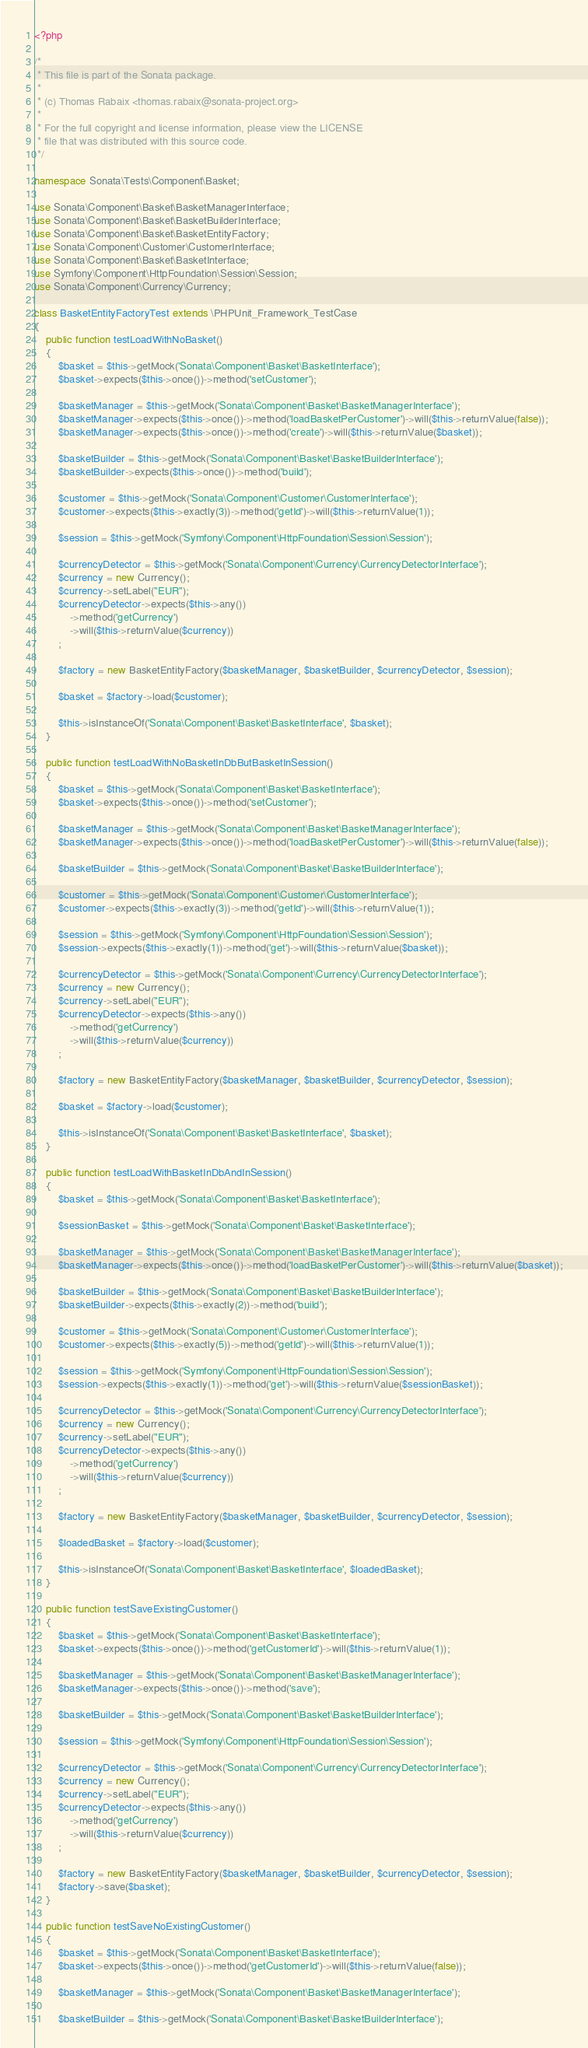<code> <loc_0><loc_0><loc_500><loc_500><_PHP_><?php

/*
 * This file is part of the Sonata package.
 *
 * (c) Thomas Rabaix <thomas.rabaix@sonata-project.org>
 *
 * For the full copyright and license information, please view the LICENSE
 * file that was distributed with this source code.
 */

namespace Sonata\Tests\Component\Basket;

use Sonata\Component\Basket\BasketManagerInterface;
use Sonata\Component\Basket\BasketBuilderInterface;
use Sonata\Component\Basket\BasketEntityFactory;
use Sonata\Component\Customer\CustomerInterface;
use Sonata\Component\Basket\BasketInterface;
use Symfony\Component\HttpFoundation\Session\Session;
use Sonata\Component\Currency\Currency;

class BasketEntityFactoryTest extends \PHPUnit_Framework_TestCase
{
    public function testLoadWithNoBasket()
    {
        $basket = $this->getMock('Sonata\Component\Basket\BasketInterface');
        $basket->expects($this->once())->method('setCustomer');

        $basketManager = $this->getMock('Sonata\Component\Basket\BasketManagerInterface');
        $basketManager->expects($this->once())->method('loadBasketPerCustomer')->will($this->returnValue(false));
        $basketManager->expects($this->once())->method('create')->will($this->returnValue($basket));

        $basketBuilder = $this->getMock('Sonata\Component\Basket\BasketBuilderInterface');
        $basketBuilder->expects($this->once())->method('build');

        $customer = $this->getMock('Sonata\Component\Customer\CustomerInterface');
        $customer->expects($this->exactly(3))->method('getId')->will($this->returnValue(1));

        $session = $this->getMock('Symfony\Component\HttpFoundation\Session\Session');

        $currencyDetector = $this->getMock('Sonata\Component\Currency\CurrencyDetectorInterface');
        $currency = new Currency();
        $currency->setLabel("EUR");
        $currencyDetector->expects($this->any())
            ->method('getCurrency')
            ->will($this->returnValue($currency))
        ;

        $factory = new BasketEntityFactory($basketManager, $basketBuilder, $currencyDetector, $session);

        $basket = $factory->load($customer);

        $this->isInstanceOf('Sonata\Component\Basket\BasketInterface', $basket);
    }

    public function testLoadWithNoBasketInDbButBasketInSession()
    {
        $basket = $this->getMock('Sonata\Component\Basket\BasketInterface');
        $basket->expects($this->once())->method('setCustomer');

        $basketManager = $this->getMock('Sonata\Component\Basket\BasketManagerInterface');
        $basketManager->expects($this->once())->method('loadBasketPerCustomer')->will($this->returnValue(false));

        $basketBuilder = $this->getMock('Sonata\Component\Basket\BasketBuilderInterface');

        $customer = $this->getMock('Sonata\Component\Customer\CustomerInterface');
        $customer->expects($this->exactly(3))->method('getId')->will($this->returnValue(1));

        $session = $this->getMock('Symfony\Component\HttpFoundation\Session\Session');
        $session->expects($this->exactly(1))->method('get')->will($this->returnValue($basket));

        $currencyDetector = $this->getMock('Sonata\Component\Currency\CurrencyDetectorInterface');
        $currency = new Currency();
        $currency->setLabel("EUR");
        $currencyDetector->expects($this->any())
            ->method('getCurrency')
            ->will($this->returnValue($currency))
        ;

        $factory = new BasketEntityFactory($basketManager, $basketBuilder, $currencyDetector, $session);

        $basket = $factory->load($customer);

        $this->isInstanceOf('Sonata\Component\Basket\BasketInterface', $basket);
    }

    public function testLoadWithBasketInDbAndInSession()
    {
        $basket = $this->getMock('Sonata\Component\Basket\BasketInterface');

        $sessionBasket = $this->getMock('Sonata\Component\Basket\BasketInterface');

        $basketManager = $this->getMock('Sonata\Component\Basket\BasketManagerInterface');
        $basketManager->expects($this->once())->method('loadBasketPerCustomer')->will($this->returnValue($basket));

        $basketBuilder = $this->getMock('Sonata\Component\Basket\BasketBuilderInterface');
        $basketBuilder->expects($this->exactly(2))->method('build');

        $customer = $this->getMock('Sonata\Component\Customer\CustomerInterface');
        $customer->expects($this->exactly(5))->method('getId')->will($this->returnValue(1));

        $session = $this->getMock('Symfony\Component\HttpFoundation\Session\Session');
        $session->expects($this->exactly(1))->method('get')->will($this->returnValue($sessionBasket));

        $currencyDetector = $this->getMock('Sonata\Component\Currency\CurrencyDetectorInterface');
        $currency = new Currency();
        $currency->setLabel("EUR");
        $currencyDetector->expects($this->any())
            ->method('getCurrency')
            ->will($this->returnValue($currency))
        ;

        $factory = new BasketEntityFactory($basketManager, $basketBuilder, $currencyDetector, $session);

        $loadedBasket = $factory->load($customer);

        $this->isInstanceOf('Sonata\Component\Basket\BasketInterface', $loadedBasket);
    }

    public function testSaveExistingCustomer()
    {
        $basket = $this->getMock('Sonata\Component\Basket\BasketInterface');
        $basket->expects($this->once())->method('getCustomerId')->will($this->returnValue(1));

        $basketManager = $this->getMock('Sonata\Component\Basket\BasketManagerInterface');
        $basketManager->expects($this->once())->method('save');

        $basketBuilder = $this->getMock('Sonata\Component\Basket\BasketBuilderInterface');

        $session = $this->getMock('Symfony\Component\HttpFoundation\Session\Session');

        $currencyDetector = $this->getMock('Sonata\Component\Currency\CurrencyDetectorInterface');
        $currency = new Currency();
        $currency->setLabel("EUR");
        $currencyDetector->expects($this->any())
            ->method('getCurrency')
            ->will($this->returnValue($currency))
        ;

        $factory = new BasketEntityFactory($basketManager, $basketBuilder, $currencyDetector, $session);
        $factory->save($basket);
    }

    public function testSaveNoExistingCustomer()
    {
        $basket = $this->getMock('Sonata\Component\Basket\BasketInterface');
        $basket->expects($this->once())->method('getCustomerId')->will($this->returnValue(false));

        $basketManager = $this->getMock('Sonata\Component\Basket\BasketManagerInterface');

        $basketBuilder = $this->getMock('Sonata\Component\Basket\BasketBuilderInterface');
</code> 